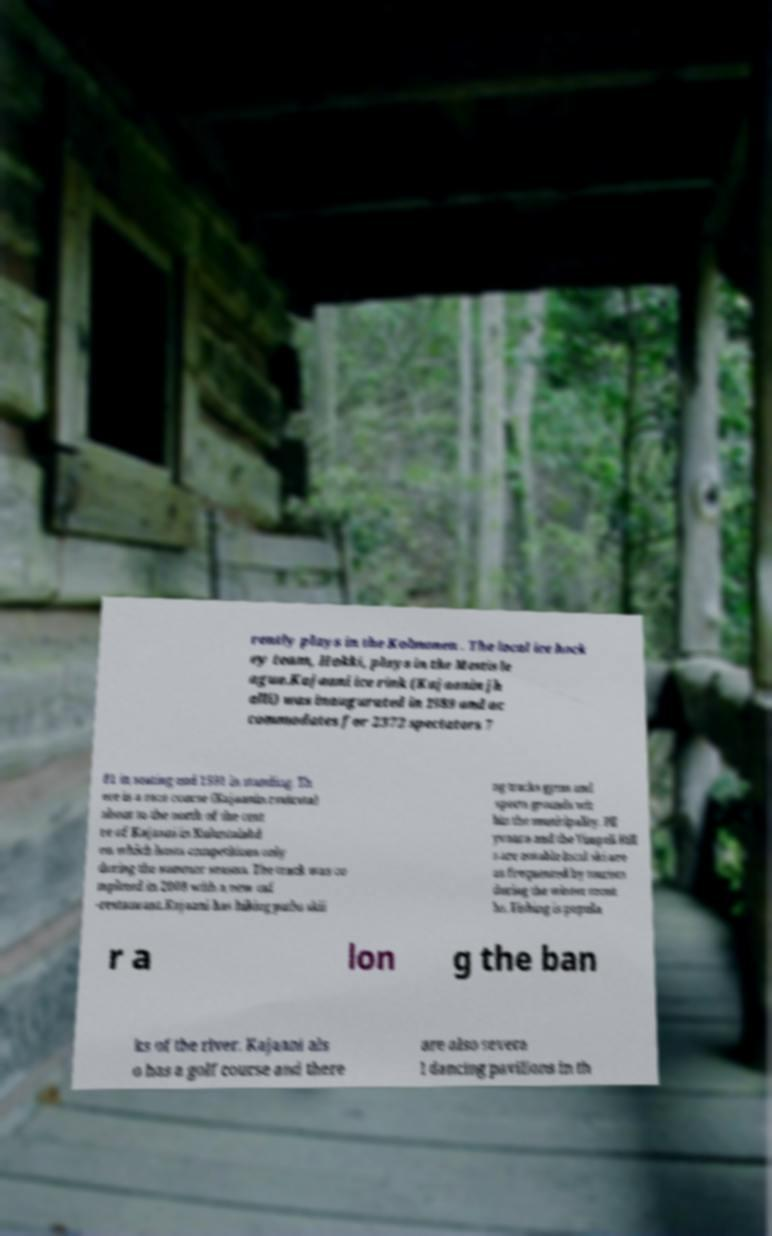For documentation purposes, I need the text within this image transcribed. Could you provide that? rently plays in the Kolmonen . The local ice hock ey team, Hokki, plays in the Mestis le ague.Kajaani ice rink (Kajaanin jh alli) was inaugurated in 1989 and ac commodates for 2372 spectators 7 81 in seating and 1591 in standing. Th ere is a race course (Kajaanin ravirata) about to the north of the cent re of Kajaani in Kuluntalahd en which hosts competitions only during the summer season. The track was co mpleted in 2008 with a new caf -restaurant.Kajaani has hiking paths skii ng tracks gyms and sports grounds wit hin the municipality. Pll yvaara and the Vimpeli Hill s are notable local ski are as frequented by tourists during the winter mont hs. Fishing is popula r a lon g the ban ks of the river. Kajaani als o has a golf course and there are also severa l dancing pavilions in th 